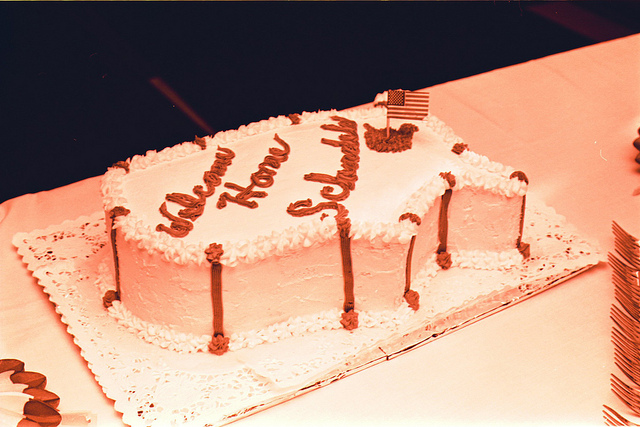Please transcribe the text in this image. welcome Home Sc 